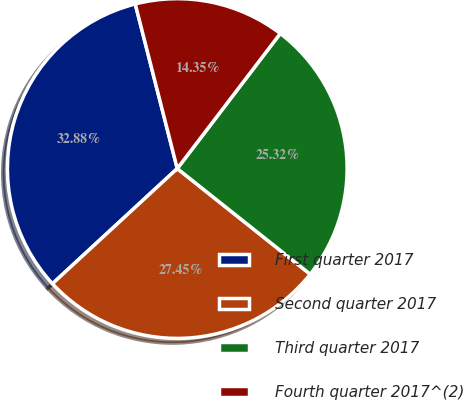Convert chart to OTSL. <chart><loc_0><loc_0><loc_500><loc_500><pie_chart><fcel>First quarter 2017<fcel>Second quarter 2017<fcel>Third quarter 2017<fcel>Fourth quarter 2017^(2)<nl><fcel>32.88%<fcel>27.45%<fcel>25.32%<fcel>14.35%<nl></chart> 